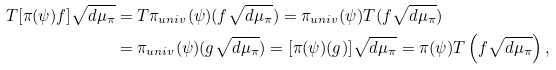Convert formula to latex. <formula><loc_0><loc_0><loc_500><loc_500>T [ \pi ( \psi ) f ] \sqrt { d \mu _ { \pi } } & = T \pi _ { u n i v } ( \psi ) ( f \sqrt { d \mu _ { \pi } } ) = \pi _ { u n i v } ( \psi ) T ( f \sqrt { d \mu _ { \pi } } ) \\ & = \pi _ { u n i v } ( \psi ) ( g \sqrt { d \mu _ { \pi } } ) = [ \pi ( \psi ) ( g ) ] \sqrt { d \mu _ { \pi } } = \pi ( \psi ) T \left ( f \sqrt { d \mu _ { \pi } } \right ) ,</formula> 